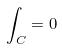Convert formula to latex. <formula><loc_0><loc_0><loc_500><loc_500>\int _ { C } = 0</formula> 